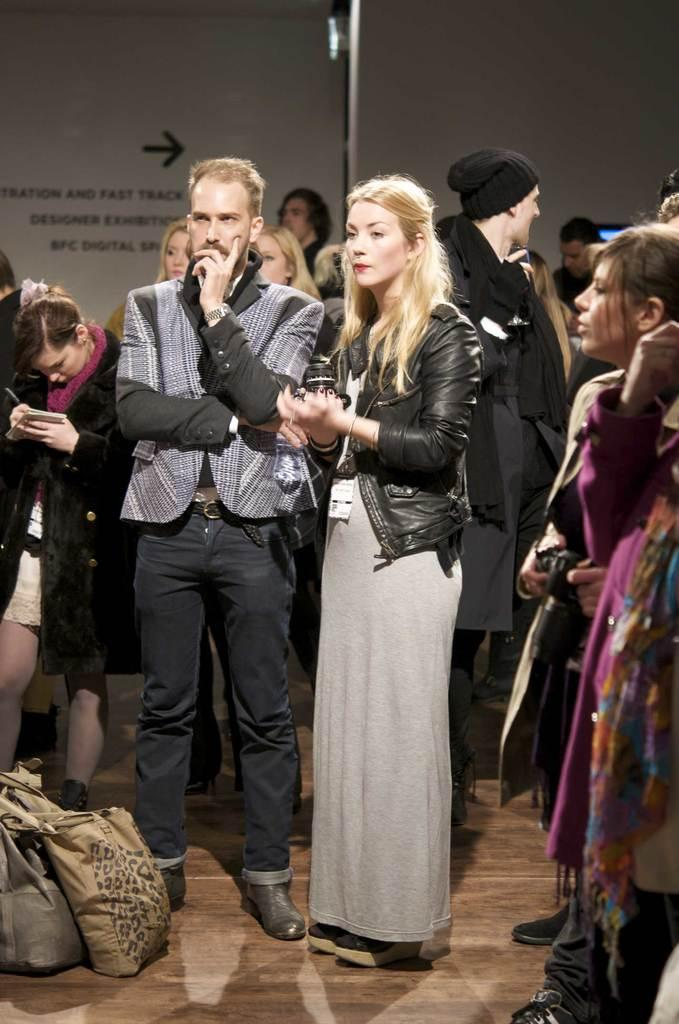What are the people in the image doing? The people in the image are standing on the floor. What objects can be seen in addition to the people? There are bags in the image. What can be seen in the background of the image? There are hoardings in the background of the image. What type of bait is being used to catch fish in the image? There is no fishing or bait present in the image. How are the people saying goodbye to each other in the image? There is no indication of people saying goodbye in the image. 